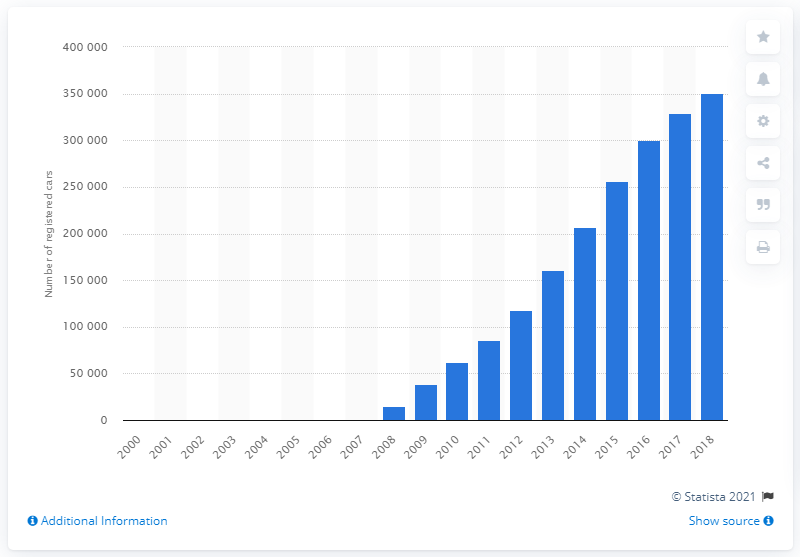Specify some key components in this picture. In 2018, a total of 350,943 Fiat 500 cars were registered in Great Britain. 